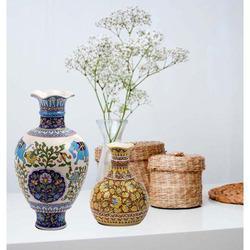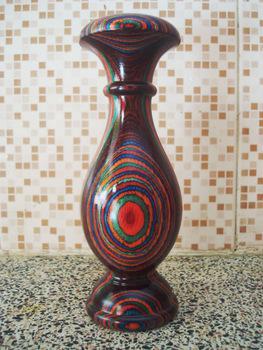The first image is the image on the left, the second image is the image on the right. For the images displayed, is the sentence "In one image, a single vase has four box-like sides that are smaller at the bottom than at the top, while one vase in a second image is dark brown and curved." factually correct? Answer yes or no. No. The first image is the image on the left, the second image is the image on the right. Assess this claim about the two images: "There is one empty vase in the image on the right.". Correct or not? Answer yes or no. Yes. 